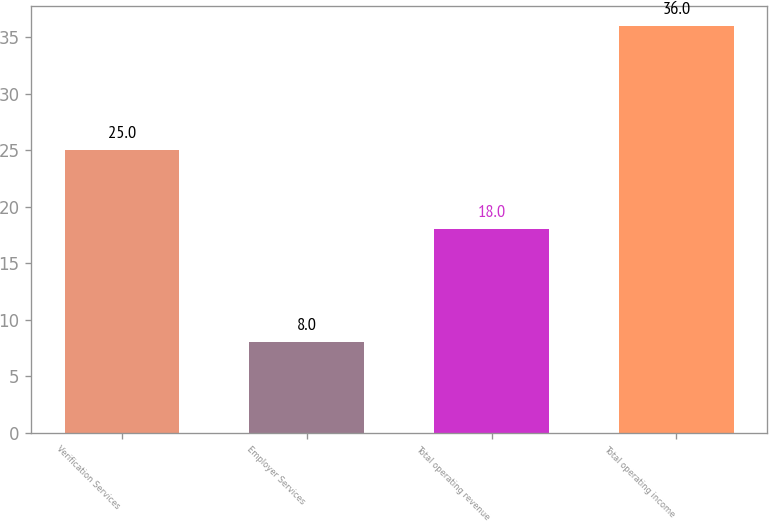Convert chart. <chart><loc_0><loc_0><loc_500><loc_500><bar_chart><fcel>Verification Services<fcel>Employer Services<fcel>Total operating revenue<fcel>Total operating income<nl><fcel>25<fcel>8<fcel>18<fcel>36<nl></chart> 